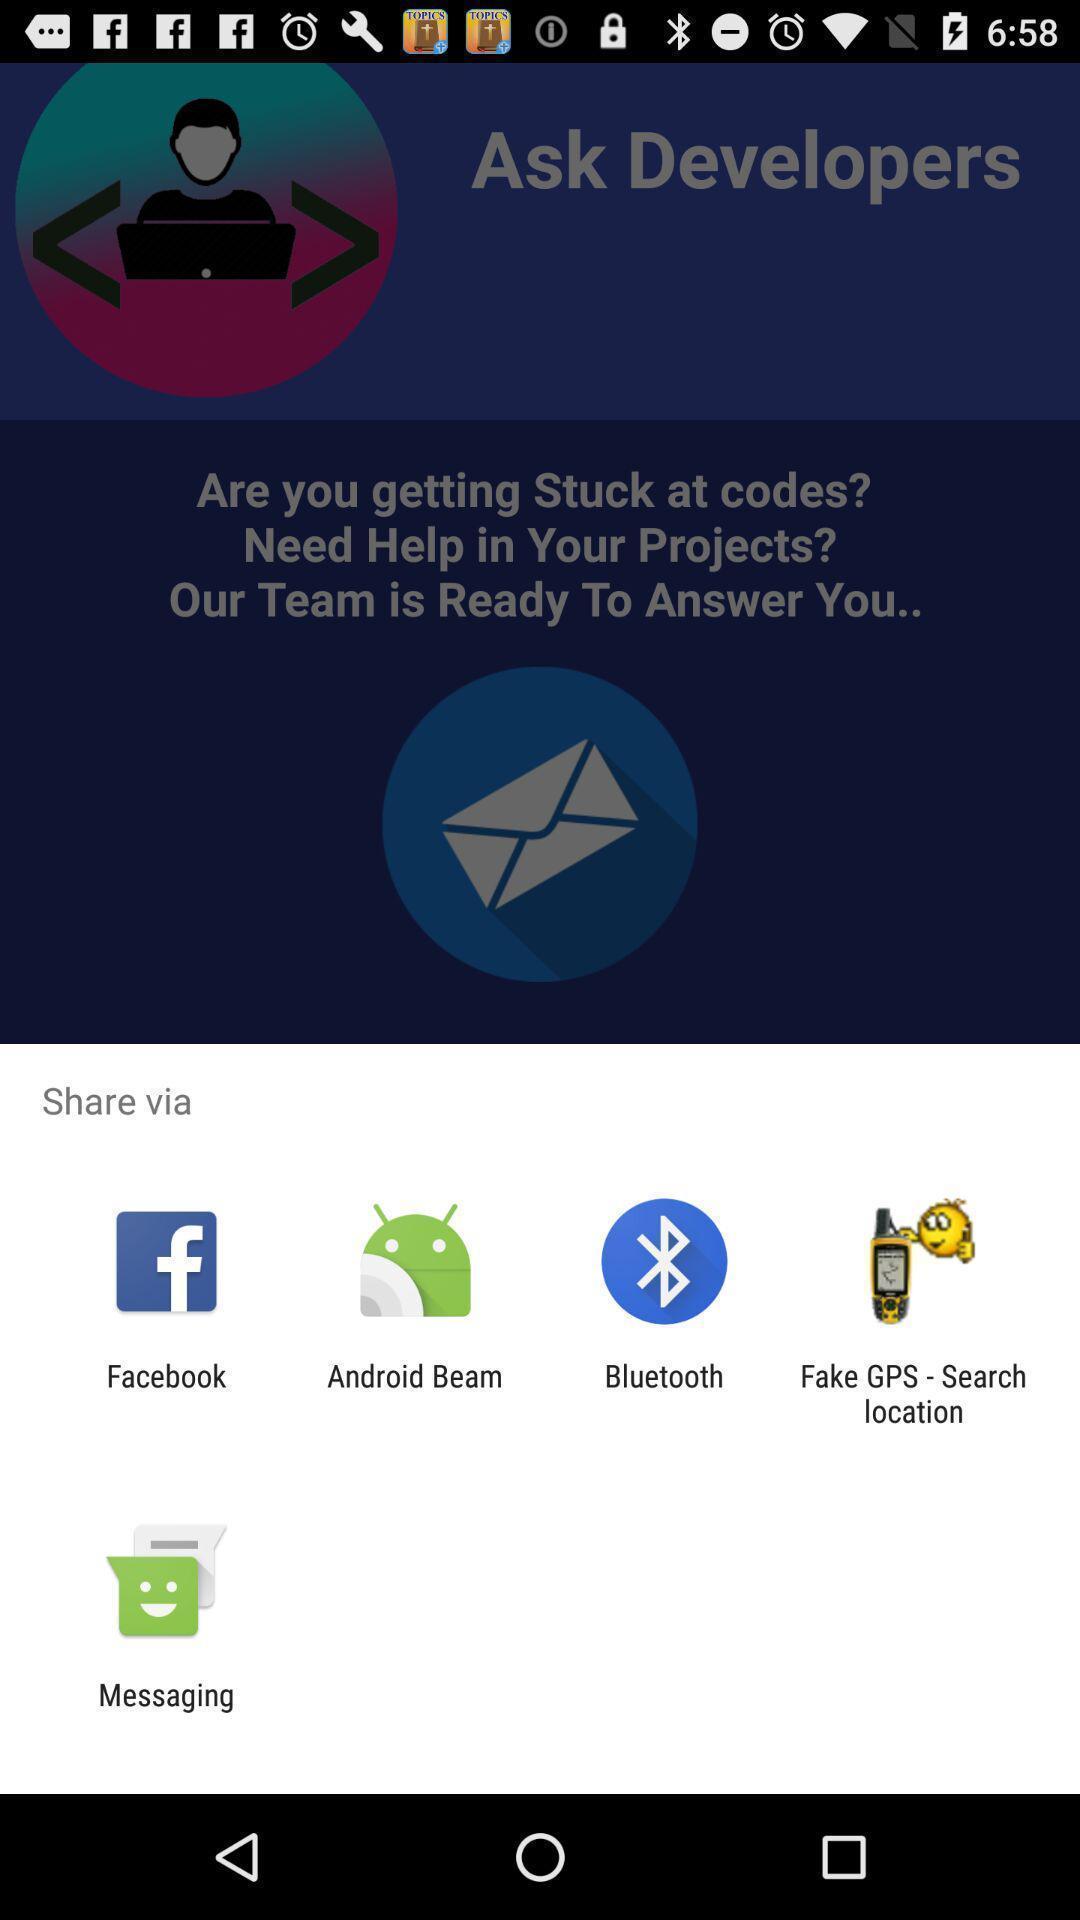Provide a textual representation of this image. Sharing via different app options. 